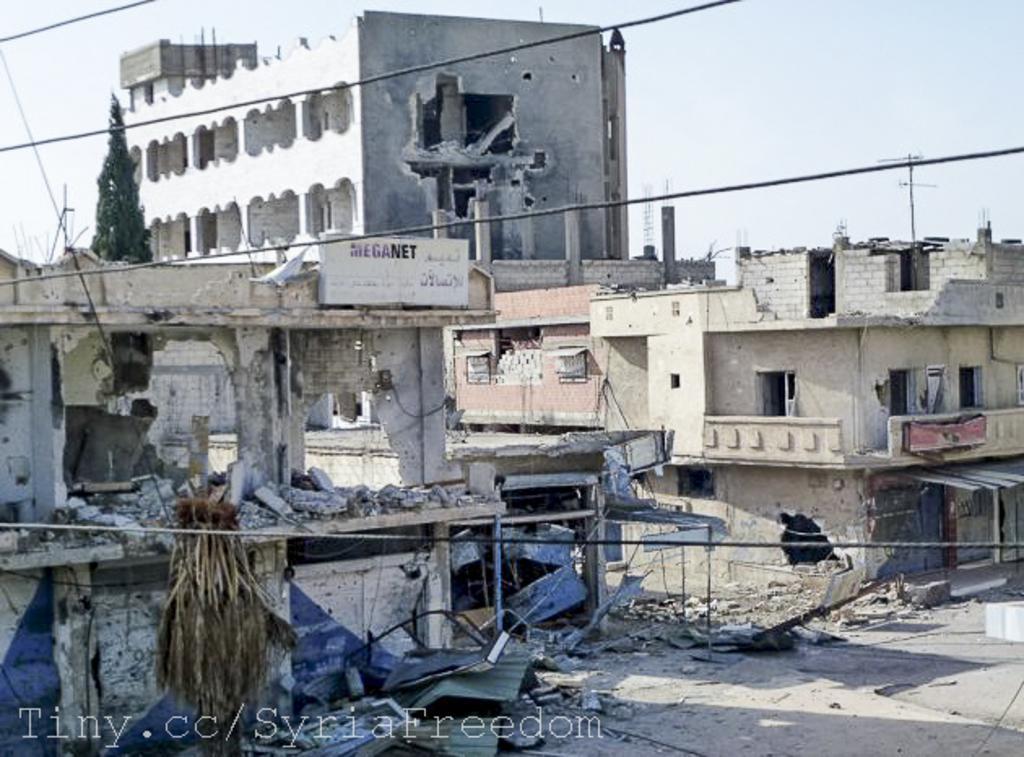Can you describe this image briefly? In the picture we can see some house buildings and some buildings are broken and some parts fell on the path and in the background we can see a part of the sky. 